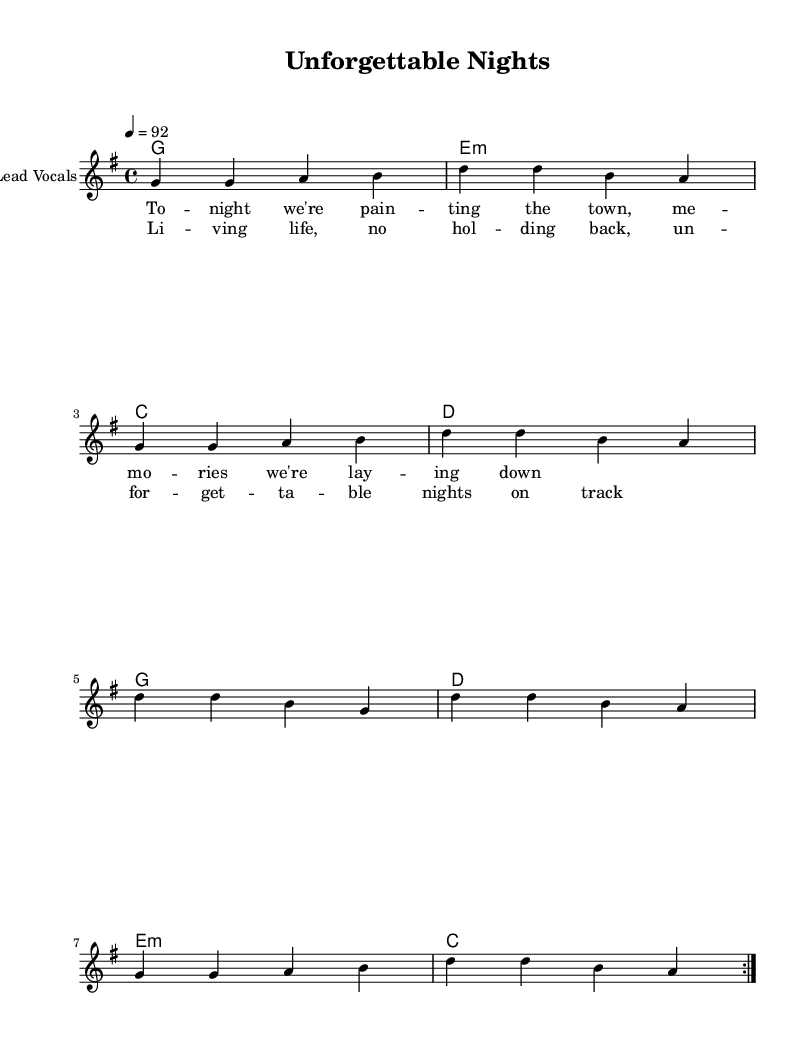What is the key signature of this music? The key signature is G major, which has one sharp (F#). You can determine the key signature by looking at the beginning of the staff where the sharps or flats are indicated.
Answer: G major What is the time signature of this music? The time signature is 4/4. This is indicated at the start of the score, where the numbers are shown as a fraction (top number indicates beats per measure, bottom number indicates the note that receives one beat).
Answer: 4/4 What is the tempo marking of this piece? The tempo marking is 92 beats per minute, as indicated in the score, specifying the speed at which the piece should be played. It is expressed numerically next to the tempo indication.
Answer: 92 How many measures are in the melody section? There are eight measures in the melody section. This can be counted by looking at the vertical lines which separate the music into measures, and counting them.
Answer: 8 What is the mood conveyed in the chorus lyrics? The mood conveyed is carefree and celebratory, indicated by the lyrics "Living life, no holding back, unforgettable nights on track," which suggest enjoyment and seizing the moment. The use of words like "living," "unforgettable," and "nights" evokes positive emotions associated with lively experiences.
Answer: Carefree Which musical genre does this piece represent? This piece represents the reggae-pop genre, which is characterized by its rhythmic style and upbeat feel, incorporating elements of reggae with pop sensibilities. This can be inferred from both the chords and the lyrical content that aligns with reggae vibes.
Answer: Reggae-pop 